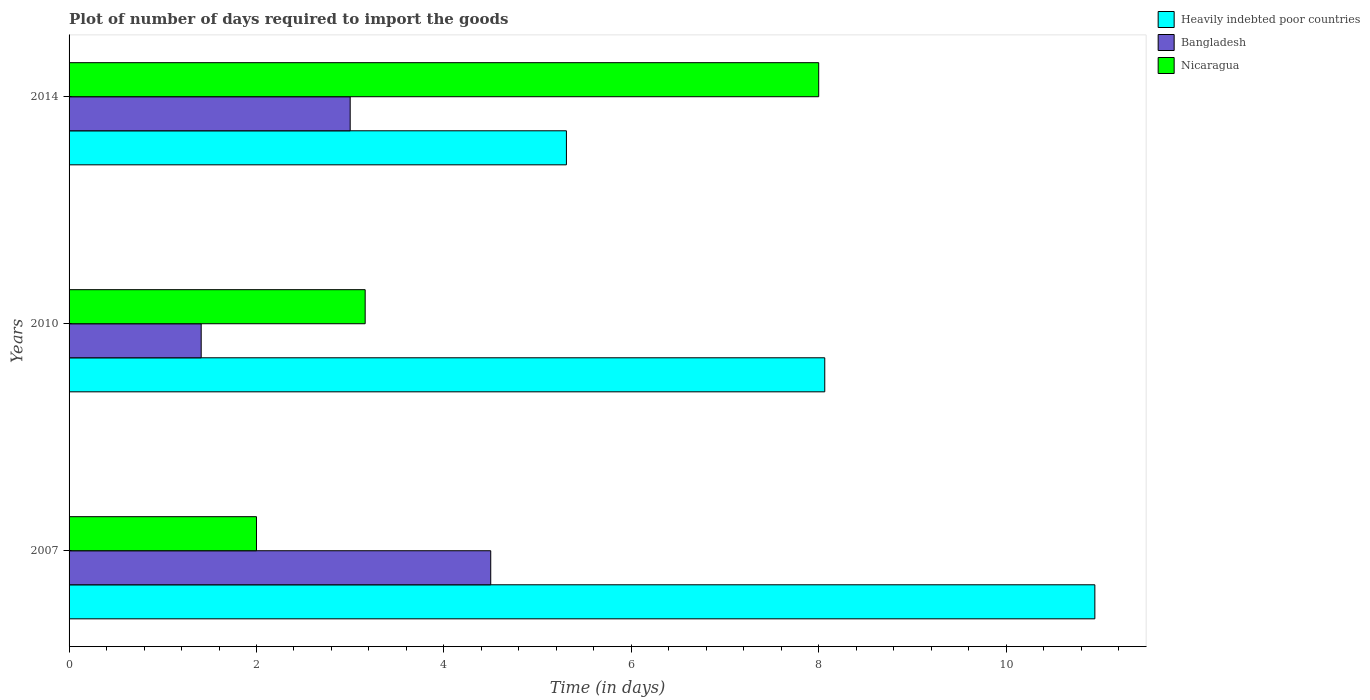How many different coloured bars are there?
Offer a very short reply. 3. How many groups of bars are there?
Your answer should be very brief. 3. Are the number of bars per tick equal to the number of legend labels?
Ensure brevity in your answer.  Yes. What is the time required to import goods in Bangladesh in 2007?
Offer a very short reply. 4.5. Across all years, what is the maximum time required to import goods in Heavily indebted poor countries?
Your answer should be very brief. 10.95. Across all years, what is the minimum time required to import goods in Heavily indebted poor countries?
Provide a succinct answer. 5.31. In which year was the time required to import goods in Nicaragua maximum?
Provide a short and direct response. 2014. What is the total time required to import goods in Bangladesh in the graph?
Offer a terse response. 8.91. What is the difference between the time required to import goods in Bangladesh in 2007 and that in 2014?
Offer a terse response. 1.5. What is the difference between the time required to import goods in Bangladesh in 2014 and the time required to import goods in Heavily indebted poor countries in 2007?
Offer a terse response. -7.95. What is the average time required to import goods in Bangladesh per year?
Your answer should be very brief. 2.97. In the year 2014, what is the difference between the time required to import goods in Heavily indebted poor countries and time required to import goods in Bangladesh?
Ensure brevity in your answer.  2.31. In how many years, is the time required to import goods in Heavily indebted poor countries greater than 5.6 days?
Provide a short and direct response. 2. Is the time required to import goods in Bangladesh in 2007 less than that in 2010?
Offer a terse response. No. Is the difference between the time required to import goods in Heavily indebted poor countries in 2007 and 2014 greater than the difference between the time required to import goods in Bangladesh in 2007 and 2014?
Make the answer very short. Yes. What is the difference between the highest and the second highest time required to import goods in Nicaragua?
Offer a very short reply. 4.84. What is the difference between the highest and the lowest time required to import goods in Nicaragua?
Give a very brief answer. 6. Is the sum of the time required to import goods in Bangladesh in 2007 and 2014 greater than the maximum time required to import goods in Heavily indebted poor countries across all years?
Make the answer very short. No. What does the 1st bar from the top in 2014 represents?
Ensure brevity in your answer.  Nicaragua. Is it the case that in every year, the sum of the time required to import goods in Nicaragua and time required to import goods in Heavily indebted poor countries is greater than the time required to import goods in Bangladesh?
Your answer should be very brief. Yes. Are the values on the major ticks of X-axis written in scientific E-notation?
Keep it short and to the point. No. Does the graph contain any zero values?
Your answer should be very brief. No. Does the graph contain grids?
Your answer should be compact. No. How are the legend labels stacked?
Provide a succinct answer. Vertical. What is the title of the graph?
Provide a short and direct response. Plot of number of days required to import the goods. Does "Gabon" appear as one of the legend labels in the graph?
Keep it short and to the point. No. What is the label or title of the X-axis?
Your response must be concise. Time (in days). What is the label or title of the Y-axis?
Offer a very short reply. Years. What is the Time (in days) of Heavily indebted poor countries in 2007?
Your answer should be compact. 10.95. What is the Time (in days) of Bangladesh in 2007?
Offer a very short reply. 4.5. What is the Time (in days) of Heavily indebted poor countries in 2010?
Your response must be concise. 8.06. What is the Time (in days) in Bangladesh in 2010?
Provide a short and direct response. 1.41. What is the Time (in days) of Nicaragua in 2010?
Keep it short and to the point. 3.16. What is the Time (in days) of Heavily indebted poor countries in 2014?
Offer a very short reply. 5.31. What is the Time (in days) in Nicaragua in 2014?
Your answer should be compact. 8. Across all years, what is the maximum Time (in days) in Heavily indebted poor countries?
Provide a succinct answer. 10.95. Across all years, what is the minimum Time (in days) in Heavily indebted poor countries?
Offer a terse response. 5.31. Across all years, what is the minimum Time (in days) in Bangladesh?
Your response must be concise. 1.41. Across all years, what is the minimum Time (in days) of Nicaragua?
Ensure brevity in your answer.  2. What is the total Time (in days) of Heavily indebted poor countries in the graph?
Give a very brief answer. 24.32. What is the total Time (in days) of Bangladesh in the graph?
Your response must be concise. 8.91. What is the total Time (in days) in Nicaragua in the graph?
Your response must be concise. 13.16. What is the difference between the Time (in days) of Heavily indebted poor countries in 2007 and that in 2010?
Your response must be concise. 2.88. What is the difference between the Time (in days) of Bangladesh in 2007 and that in 2010?
Offer a very short reply. 3.09. What is the difference between the Time (in days) of Nicaragua in 2007 and that in 2010?
Your response must be concise. -1.16. What is the difference between the Time (in days) in Heavily indebted poor countries in 2007 and that in 2014?
Provide a succinct answer. 5.64. What is the difference between the Time (in days) in Bangladesh in 2007 and that in 2014?
Your response must be concise. 1.5. What is the difference between the Time (in days) of Nicaragua in 2007 and that in 2014?
Your answer should be compact. -6. What is the difference between the Time (in days) in Heavily indebted poor countries in 2010 and that in 2014?
Make the answer very short. 2.76. What is the difference between the Time (in days) in Bangladesh in 2010 and that in 2014?
Your answer should be very brief. -1.59. What is the difference between the Time (in days) in Nicaragua in 2010 and that in 2014?
Give a very brief answer. -4.84. What is the difference between the Time (in days) in Heavily indebted poor countries in 2007 and the Time (in days) in Bangladesh in 2010?
Your answer should be compact. 9.54. What is the difference between the Time (in days) in Heavily indebted poor countries in 2007 and the Time (in days) in Nicaragua in 2010?
Keep it short and to the point. 7.79. What is the difference between the Time (in days) of Bangladesh in 2007 and the Time (in days) of Nicaragua in 2010?
Provide a short and direct response. 1.34. What is the difference between the Time (in days) in Heavily indebted poor countries in 2007 and the Time (in days) in Bangladesh in 2014?
Your response must be concise. 7.95. What is the difference between the Time (in days) in Heavily indebted poor countries in 2007 and the Time (in days) in Nicaragua in 2014?
Offer a terse response. 2.95. What is the difference between the Time (in days) of Bangladesh in 2007 and the Time (in days) of Nicaragua in 2014?
Provide a succinct answer. -3.5. What is the difference between the Time (in days) of Heavily indebted poor countries in 2010 and the Time (in days) of Bangladesh in 2014?
Give a very brief answer. 5.06. What is the difference between the Time (in days) in Heavily indebted poor countries in 2010 and the Time (in days) in Nicaragua in 2014?
Your response must be concise. 0.06. What is the difference between the Time (in days) in Bangladesh in 2010 and the Time (in days) in Nicaragua in 2014?
Ensure brevity in your answer.  -6.59. What is the average Time (in days) in Heavily indebted poor countries per year?
Ensure brevity in your answer.  8.11. What is the average Time (in days) in Bangladesh per year?
Your answer should be very brief. 2.97. What is the average Time (in days) in Nicaragua per year?
Ensure brevity in your answer.  4.39. In the year 2007, what is the difference between the Time (in days) of Heavily indebted poor countries and Time (in days) of Bangladesh?
Your response must be concise. 6.45. In the year 2007, what is the difference between the Time (in days) in Heavily indebted poor countries and Time (in days) in Nicaragua?
Give a very brief answer. 8.95. In the year 2007, what is the difference between the Time (in days) of Bangladesh and Time (in days) of Nicaragua?
Give a very brief answer. 2.5. In the year 2010, what is the difference between the Time (in days) in Heavily indebted poor countries and Time (in days) in Bangladesh?
Your response must be concise. 6.65. In the year 2010, what is the difference between the Time (in days) of Heavily indebted poor countries and Time (in days) of Nicaragua?
Your response must be concise. 4.9. In the year 2010, what is the difference between the Time (in days) in Bangladesh and Time (in days) in Nicaragua?
Provide a succinct answer. -1.75. In the year 2014, what is the difference between the Time (in days) in Heavily indebted poor countries and Time (in days) in Bangladesh?
Your response must be concise. 2.31. In the year 2014, what is the difference between the Time (in days) of Heavily indebted poor countries and Time (in days) of Nicaragua?
Offer a very short reply. -2.69. What is the ratio of the Time (in days) in Heavily indebted poor countries in 2007 to that in 2010?
Your answer should be compact. 1.36. What is the ratio of the Time (in days) of Bangladesh in 2007 to that in 2010?
Keep it short and to the point. 3.19. What is the ratio of the Time (in days) in Nicaragua in 2007 to that in 2010?
Offer a very short reply. 0.63. What is the ratio of the Time (in days) in Heavily indebted poor countries in 2007 to that in 2014?
Your response must be concise. 2.06. What is the ratio of the Time (in days) in Nicaragua in 2007 to that in 2014?
Give a very brief answer. 0.25. What is the ratio of the Time (in days) of Heavily indebted poor countries in 2010 to that in 2014?
Give a very brief answer. 1.52. What is the ratio of the Time (in days) of Bangladesh in 2010 to that in 2014?
Make the answer very short. 0.47. What is the ratio of the Time (in days) of Nicaragua in 2010 to that in 2014?
Give a very brief answer. 0.4. What is the difference between the highest and the second highest Time (in days) of Heavily indebted poor countries?
Keep it short and to the point. 2.88. What is the difference between the highest and the second highest Time (in days) of Bangladesh?
Keep it short and to the point. 1.5. What is the difference between the highest and the second highest Time (in days) of Nicaragua?
Your answer should be compact. 4.84. What is the difference between the highest and the lowest Time (in days) of Heavily indebted poor countries?
Your response must be concise. 5.64. What is the difference between the highest and the lowest Time (in days) of Bangladesh?
Give a very brief answer. 3.09. What is the difference between the highest and the lowest Time (in days) of Nicaragua?
Make the answer very short. 6. 